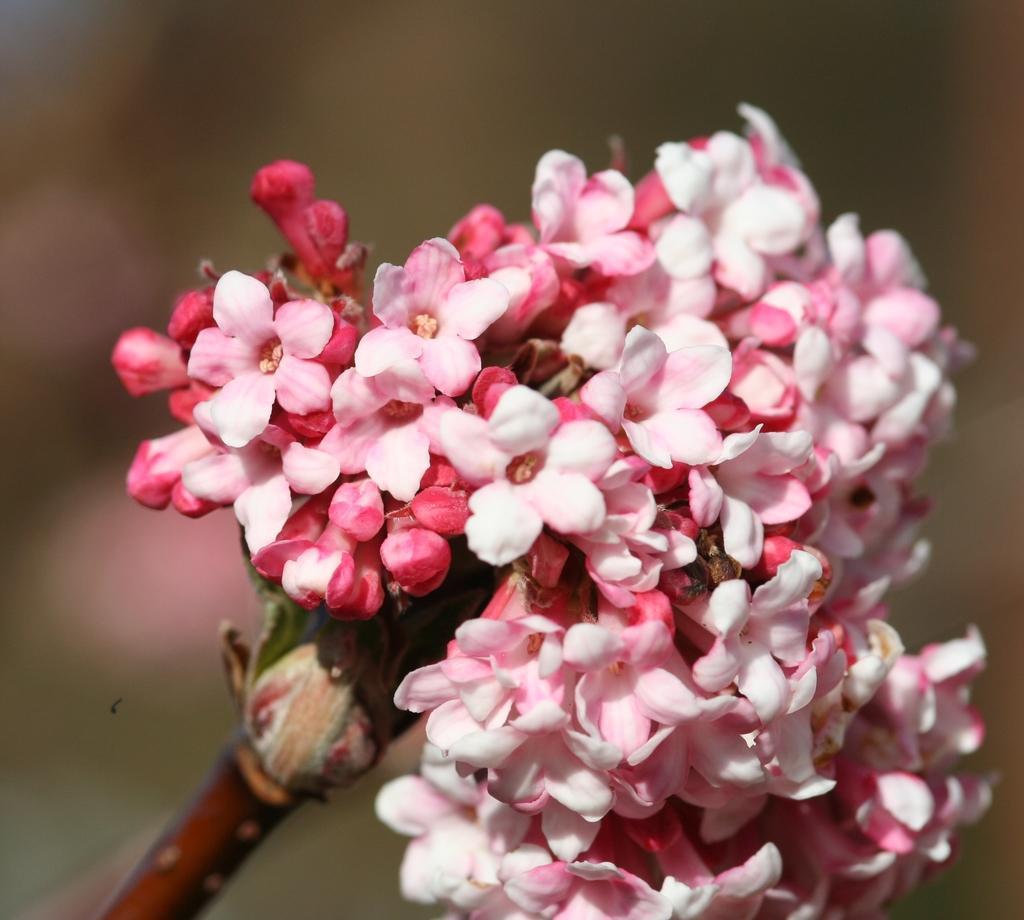In one or two sentences, can you explain what this image depicts? In this image there are flowers, in the background it is blurred. 